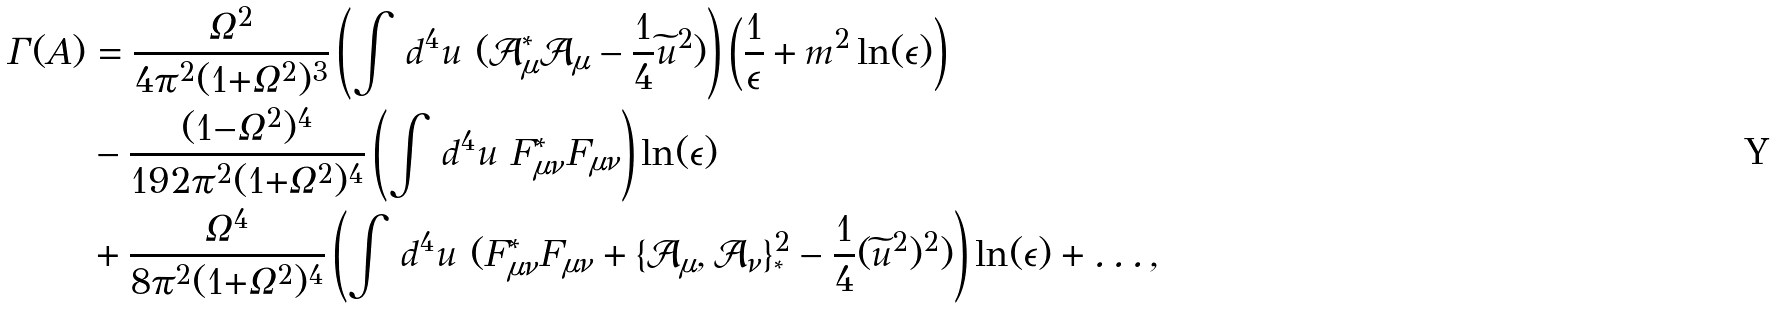<formula> <loc_0><loc_0><loc_500><loc_500>\Gamma ( A ) & = \frac { \Omega ^ { 2 } } { 4 \pi ^ { 2 } ( 1 { + } \Omega ^ { 2 } ) ^ { 3 } } \left ( \int \, d ^ { 4 } u \ ( \mathcal { A } _ { \mu } ^ { * } \mathcal { A } _ { \mu } - \frac { 1 } { 4 } \widetilde { u } ^ { 2 } ) \right ) \left ( \frac { 1 } { \epsilon } + m ^ { 2 } \ln ( \epsilon ) \right ) \\ & - \frac { ( 1 { - } \Omega ^ { 2 } ) ^ { 4 } } { 1 9 2 \pi ^ { 2 } ( 1 { + } \Omega ^ { 2 } ) ^ { 4 } } \left ( \int \, d ^ { 4 } u \ F _ { \mu \nu } ^ { * } F _ { \mu \nu } \right ) \ln ( \epsilon ) \\ & + \frac { \Omega ^ { 4 } } { 8 \pi ^ { 2 } ( 1 { + } \Omega ^ { 2 } ) ^ { 4 } } \left ( \int \, d ^ { 4 } u \ ( F _ { \mu \nu } ^ { * } F _ { \mu \nu } + \{ \mathcal { A } _ { \mu } , \mathcal { A } _ { \nu } \} _ { ^ { * } } ^ { 2 } - \frac { 1 } { 4 } ( \widetilde { u } ^ { 2 } ) ^ { 2 } ) \right ) \ln ( \epsilon ) + \dots ,</formula> 